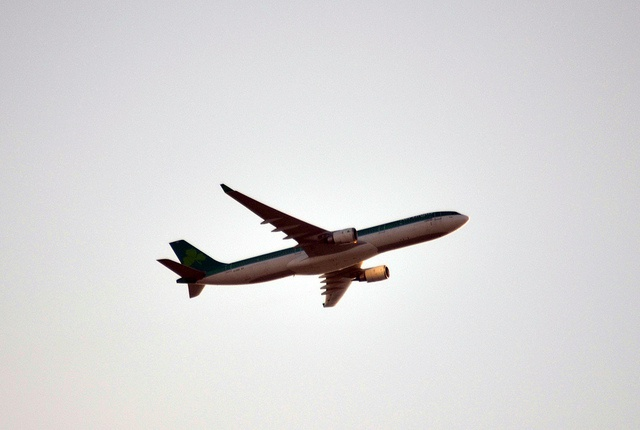Describe the objects in this image and their specific colors. I can see a airplane in lightgray, black, maroon, gray, and brown tones in this image. 